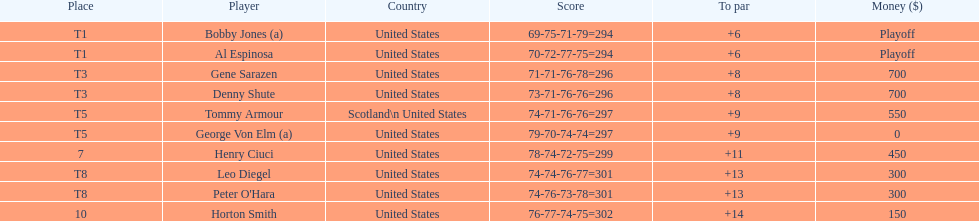Who finished next after bobby jones and al espinosa? Gene Sarazen, Denny Shute. Parse the full table. {'header': ['Place', 'Player', 'Country', 'Score', 'To par', 'Money ($)'], 'rows': [['T1', 'Bobby Jones (a)', 'United States', '69-75-71-79=294', '+6', 'Playoff'], ['T1', 'Al Espinosa', 'United States', '70-72-77-75=294', '+6', 'Playoff'], ['T3', 'Gene Sarazen', 'United States', '71-71-76-78=296', '+8', '700'], ['T3', 'Denny Shute', 'United States', '73-71-76-76=296', '+8', '700'], ['T5', 'Tommy Armour', 'Scotland\\n\xa0United States', '74-71-76-76=297', '+9', '550'], ['T5', 'George Von Elm (a)', 'United States', '79-70-74-74=297', '+9', '0'], ['7', 'Henry Ciuci', 'United States', '78-74-72-75=299', '+11', '450'], ['T8', 'Leo Diegel', 'United States', '74-74-76-77=301', '+13', '300'], ['T8', "Peter O'Hara", 'United States', '74-76-73-78=301', '+13', '300'], ['10', 'Horton Smith', 'United States', '76-77-74-75=302', '+14', '150']]} 